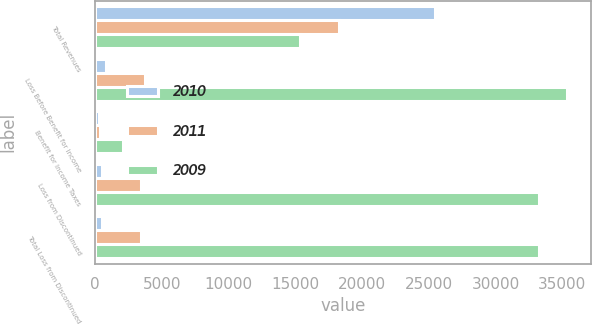Convert chart. <chart><loc_0><loc_0><loc_500><loc_500><stacked_bar_chart><ecel><fcel>Total Revenues<fcel>Loss Before Benefit for Income<fcel>Benefit for Income Taxes<fcel>Loss from Discontinued<fcel>Total Loss from Discontinued<nl><fcel>2010<fcel>25468<fcel>849<fcel>330<fcel>519<fcel>519<nl><fcel>2011<fcel>18284<fcel>3756<fcel>351<fcel>3405<fcel>3405<nl><fcel>2009<fcel>15353<fcel>35350<fcel>2104<fcel>33246<fcel>33246<nl></chart> 